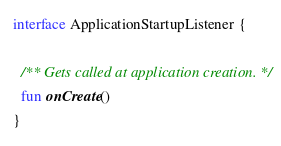Convert code to text. <code><loc_0><loc_0><loc_500><loc_500><_Kotlin_>interface ApplicationStartupListener {

  /** Gets called at application creation. */
  fun onCreate()
}
</code> 